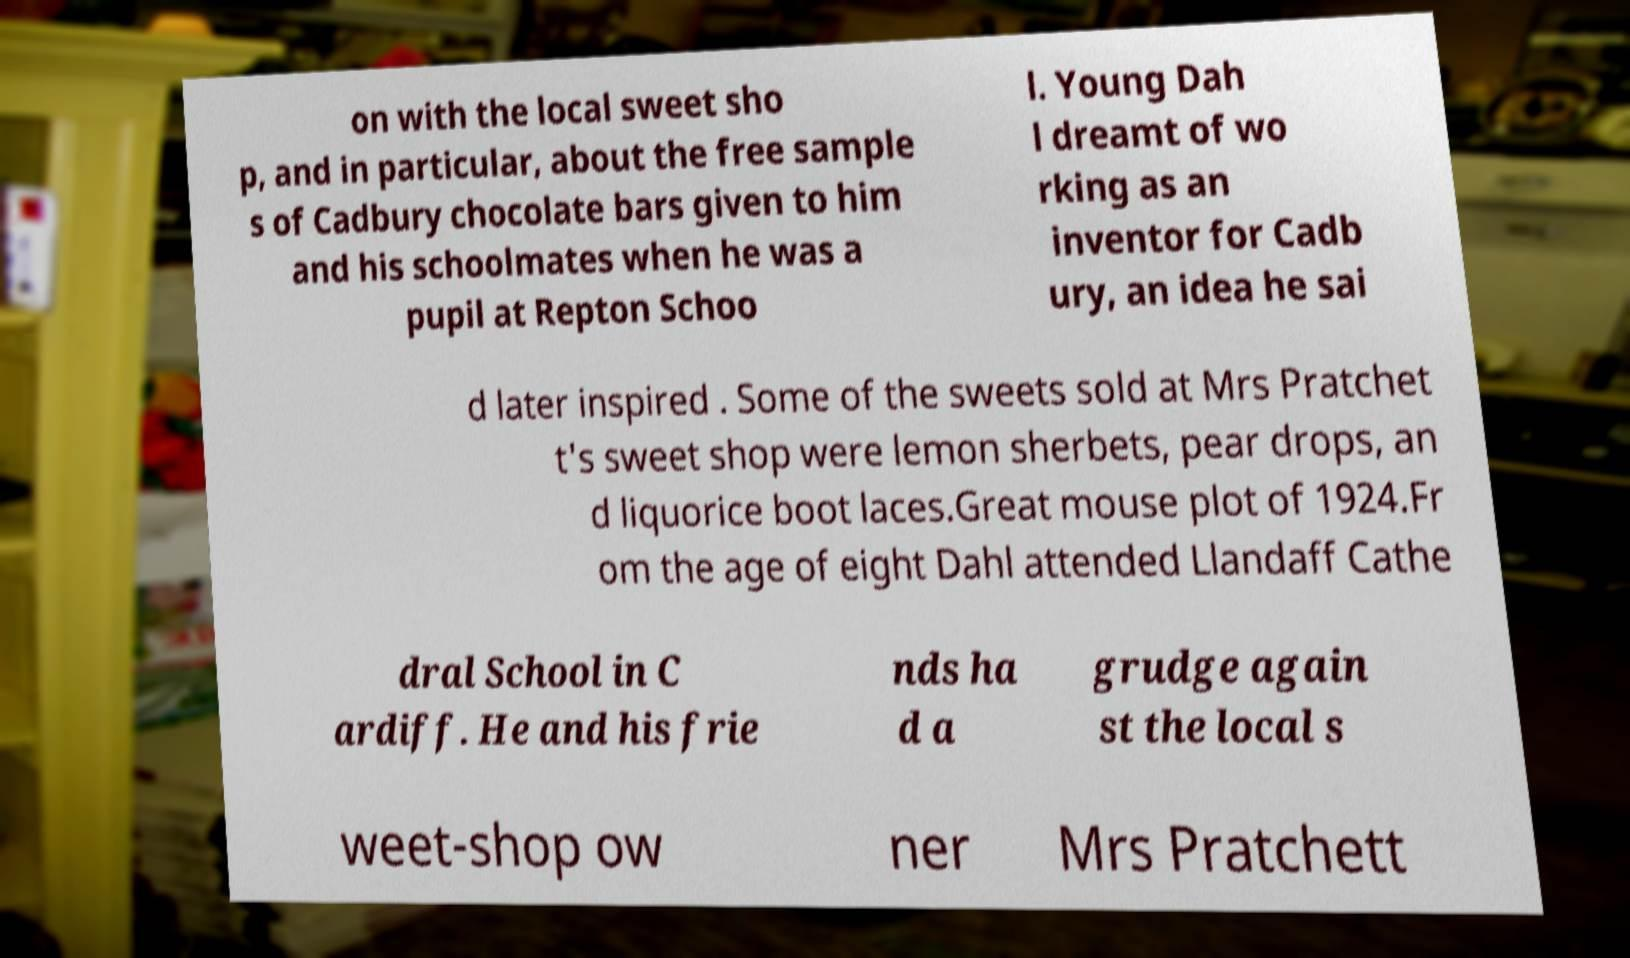What messages or text are displayed in this image? I need them in a readable, typed format. on with the local sweet sho p, and in particular, about the free sample s of Cadbury chocolate bars given to him and his schoolmates when he was a pupil at Repton Schoo l. Young Dah l dreamt of wo rking as an inventor for Cadb ury, an idea he sai d later inspired . Some of the sweets sold at Mrs Pratchet t's sweet shop were lemon sherbets, pear drops, an d liquorice boot laces.Great mouse plot of 1924.Fr om the age of eight Dahl attended Llandaff Cathe dral School in C ardiff. He and his frie nds ha d a grudge again st the local s weet-shop ow ner Mrs Pratchett 